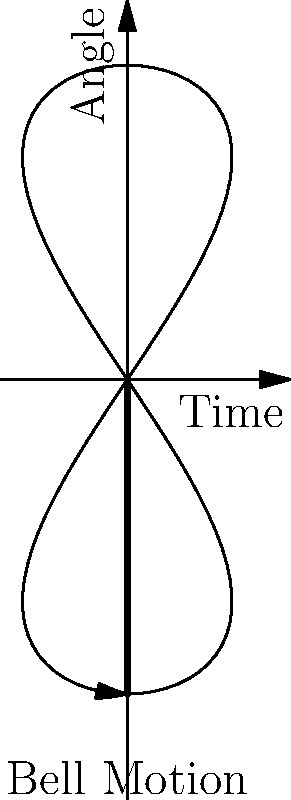In a historic Norwegian church tower, a bell with a mass of 500 kg is suspended from a pivot point and swings like a pendulum. The bell's motion is represented by the diagram above. If the maximum angle of swing is 30 degrees from vertical, what is the approximate maximum kinetic energy of the bell at the bottom of its swing? Assume $g = 9.8 \text{ m/s}^2$ and neglect air resistance. To solve this problem, we'll follow these steps:

1. Calculate the change in height of the bell's center of mass:
   Let $L$ be the length of the pendulum (bell to pivot point).
   $\Delta h = L - L \cos \theta = L(1 - \cos 30°)$

2. Use conservation of energy to find the maximum velocity:
   At the highest point, all energy is potential. At the lowest point, all energy is kinetic.
   $mgh = \frac{1}{2}mv^2$
   $v = \sqrt{2gh} = \sqrt{2g L(1 - \cos 30°)}$

3. Calculate the maximum kinetic energy:
   $KE_{max} = \frac{1}{2}mv^2 = \frac{1}{2}m(2g L(1 - \cos 30°)) = mgL(1 - \cos 30°)$

4. Substitute known values:
   $m = 500 \text{ kg}$
   $g = 9.8 \text{ m/s}^2$
   $1 - \cos 30° \approx 0.134$
   
   We don't know $L$, but it's typically around 2-3 meters for a church bell.
   Let's assume $L = 2.5 \text{ m}$

5. Calculate the final result:
   $KE_{max} = 500 \cdot 9.8 \cdot 2.5 \cdot 0.134 \approx 1640 \text{ J}$
Answer: Approximately 1640 J 